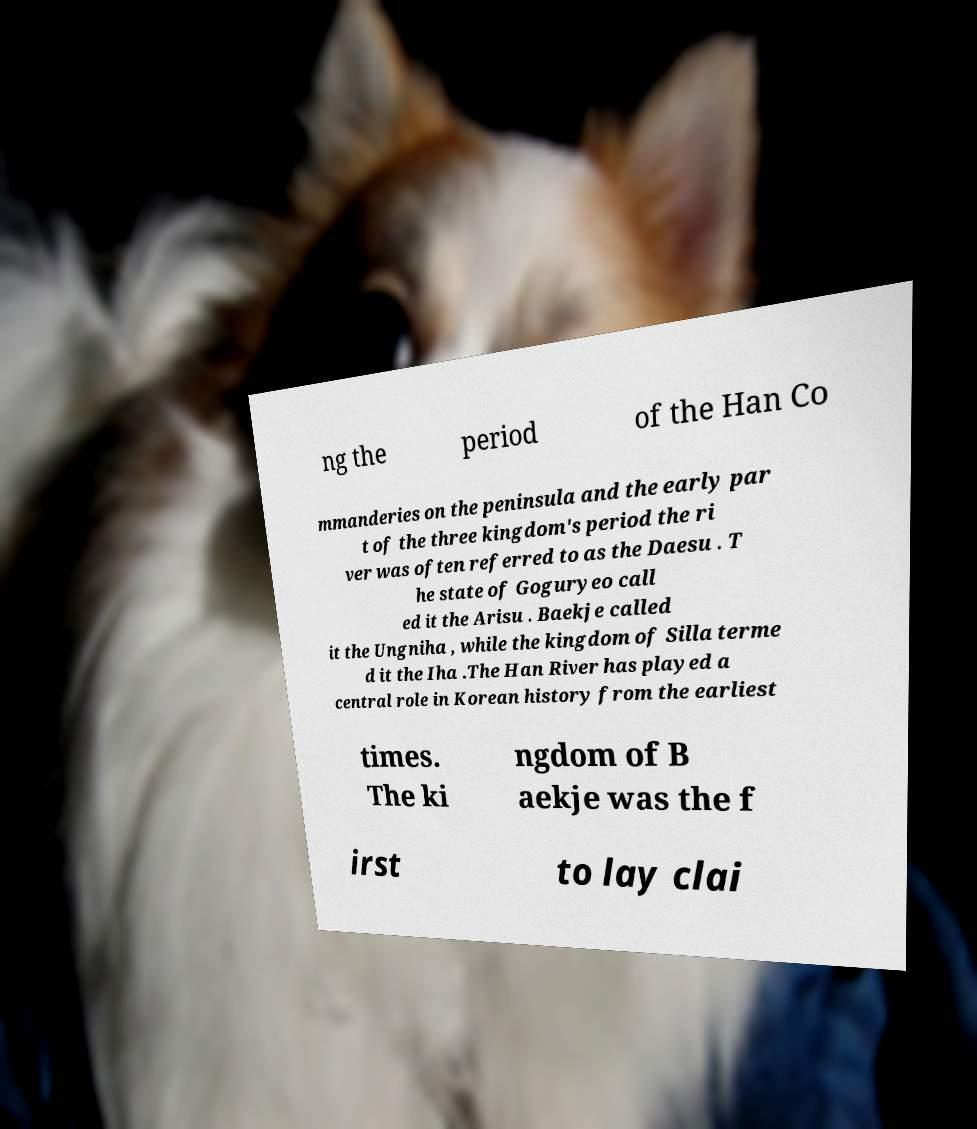Please read and relay the text visible in this image. What does it say? ng the period of the Han Co mmanderies on the peninsula and the early par t of the three kingdom's period the ri ver was often referred to as the Daesu . T he state of Goguryeo call ed it the Arisu . Baekje called it the Ungniha , while the kingdom of Silla terme d it the Iha .The Han River has played a central role in Korean history from the earliest times. The ki ngdom of B aekje was the f irst to lay clai 